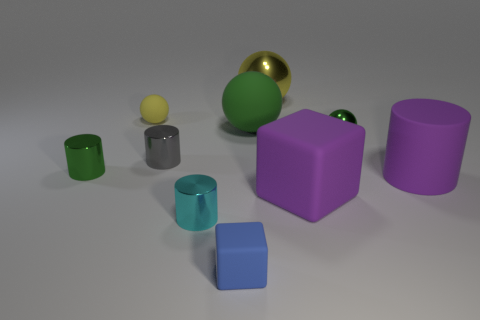Subtract all small green balls. How many balls are left? 3 Subtract all gray cylinders. How many cylinders are left? 3 Subtract all brown cubes. How many yellow balls are left? 2 Subtract 1 cylinders. How many cylinders are left? 3 Subtract all blue cylinders. Subtract all red balls. How many cylinders are left? 4 Subtract all big rubber spheres. Subtract all tiny gray shiny objects. How many objects are left? 8 Add 6 large yellow metal objects. How many large yellow metal objects are left? 7 Add 3 green cylinders. How many green cylinders exist? 4 Subtract 0 cyan cubes. How many objects are left? 10 Subtract all cubes. How many objects are left? 8 